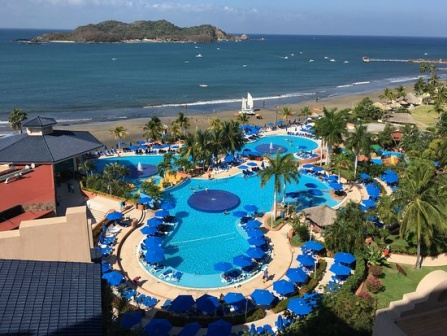What might a perfect day at this resort look like for a family with young children? A perfect day at this resort for a family with young children starts with a leisurely breakfast at one of the resort's charming outdoor cafes, where parents can enjoy their coffee while children marvel at the view of the pool and the ocean beyond. After breakfast, the family heads to the pool area where the kids can splash around in the shallow parts, play with pool toys, or engage in some poolside games organized by the resort staff. 

While the children are busy, parents can relax on the blue lounge chairs under the umbrellas, keeping an eye on their kids while soaking up the sunshine or reading a good book. As midday approaches, they might take a break for lunch at one of the resort’s eateries, serving delightful and kid-friendly meals.

Afternoons could be spent participating in one of the resort's organized activities, such as a pottery painting class, a nature scavenger hunt, or a family beach volleyball match. If the family is feeling adventurous, they might rent one of the boats seen dotting the coast for a brief water exploration or even venture to the distant small island for a picnic.

As the sun begins to set, they head to the beach, where they build sandcastles and search for seashells, enjoying the glorious sight of the sunset reflecting off the water. Dinner could be a special treat with a seaside barbecue, accompanied by live music or a themed performance geared towards children, ensuring entertainment for the entire family.

The day concludes with a calm evening walk within the resort, perhaps stopping by the gift shop for souvenirs, and then retiring to their comfortable room, ending their perfect day with a storybook reading, reminiscing about the day's adventures, and looking forward to another fun-filled day. 